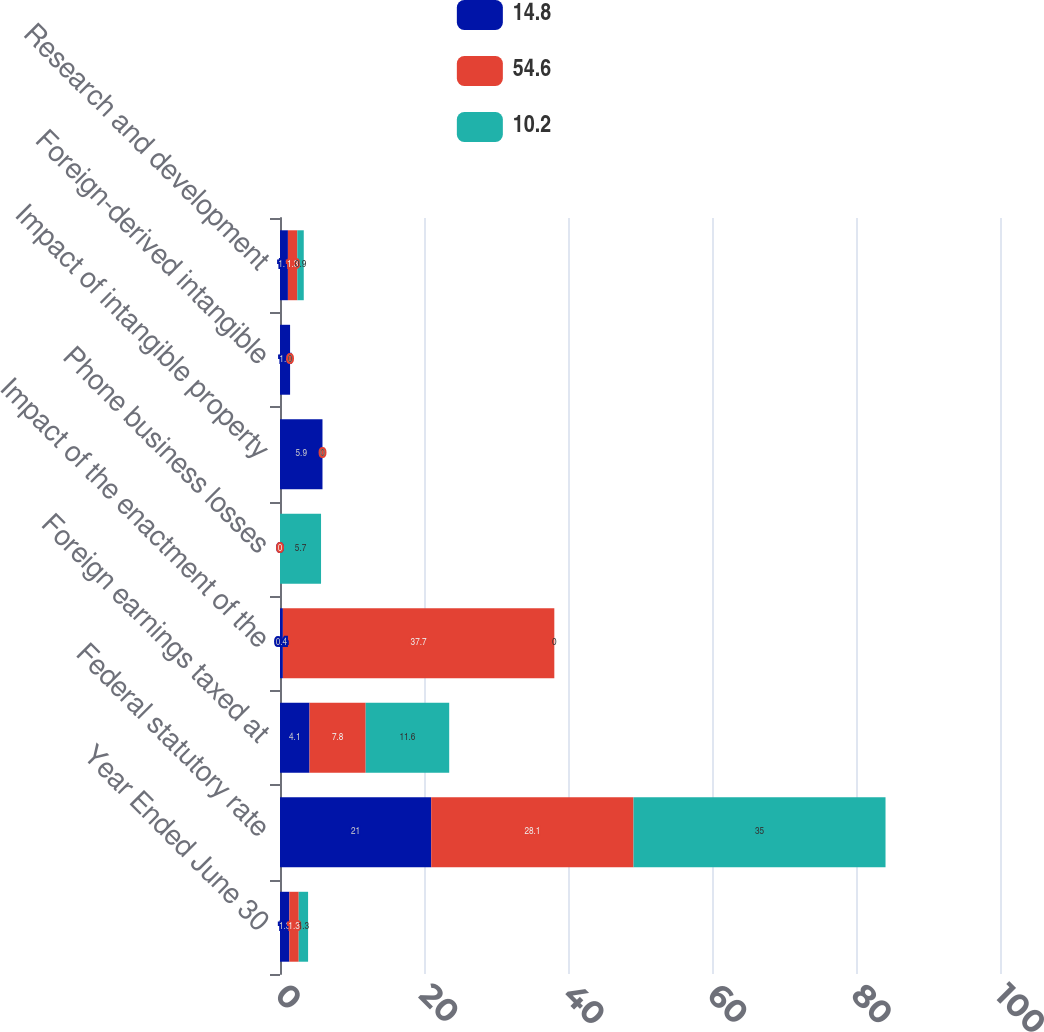Convert chart. <chart><loc_0><loc_0><loc_500><loc_500><stacked_bar_chart><ecel><fcel>Year Ended June 30<fcel>Federal statutory rate<fcel>Foreign earnings taxed at<fcel>Impact of the enactment of the<fcel>Phone business losses<fcel>Impact of intangible property<fcel>Foreign-derived intangible<fcel>Research and development<nl><fcel>14.8<fcel>1.3<fcel>21<fcel>4.1<fcel>0.4<fcel>0<fcel>5.9<fcel>1.4<fcel>1.1<nl><fcel>54.6<fcel>1.3<fcel>28.1<fcel>7.8<fcel>37.7<fcel>0<fcel>0<fcel>0<fcel>1.3<nl><fcel>10.2<fcel>1.3<fcel>35<fcel>11.6<fcel>0<fcel>5.7<fcel>0<fcel>0<fcel>0.9<nl></chart> 